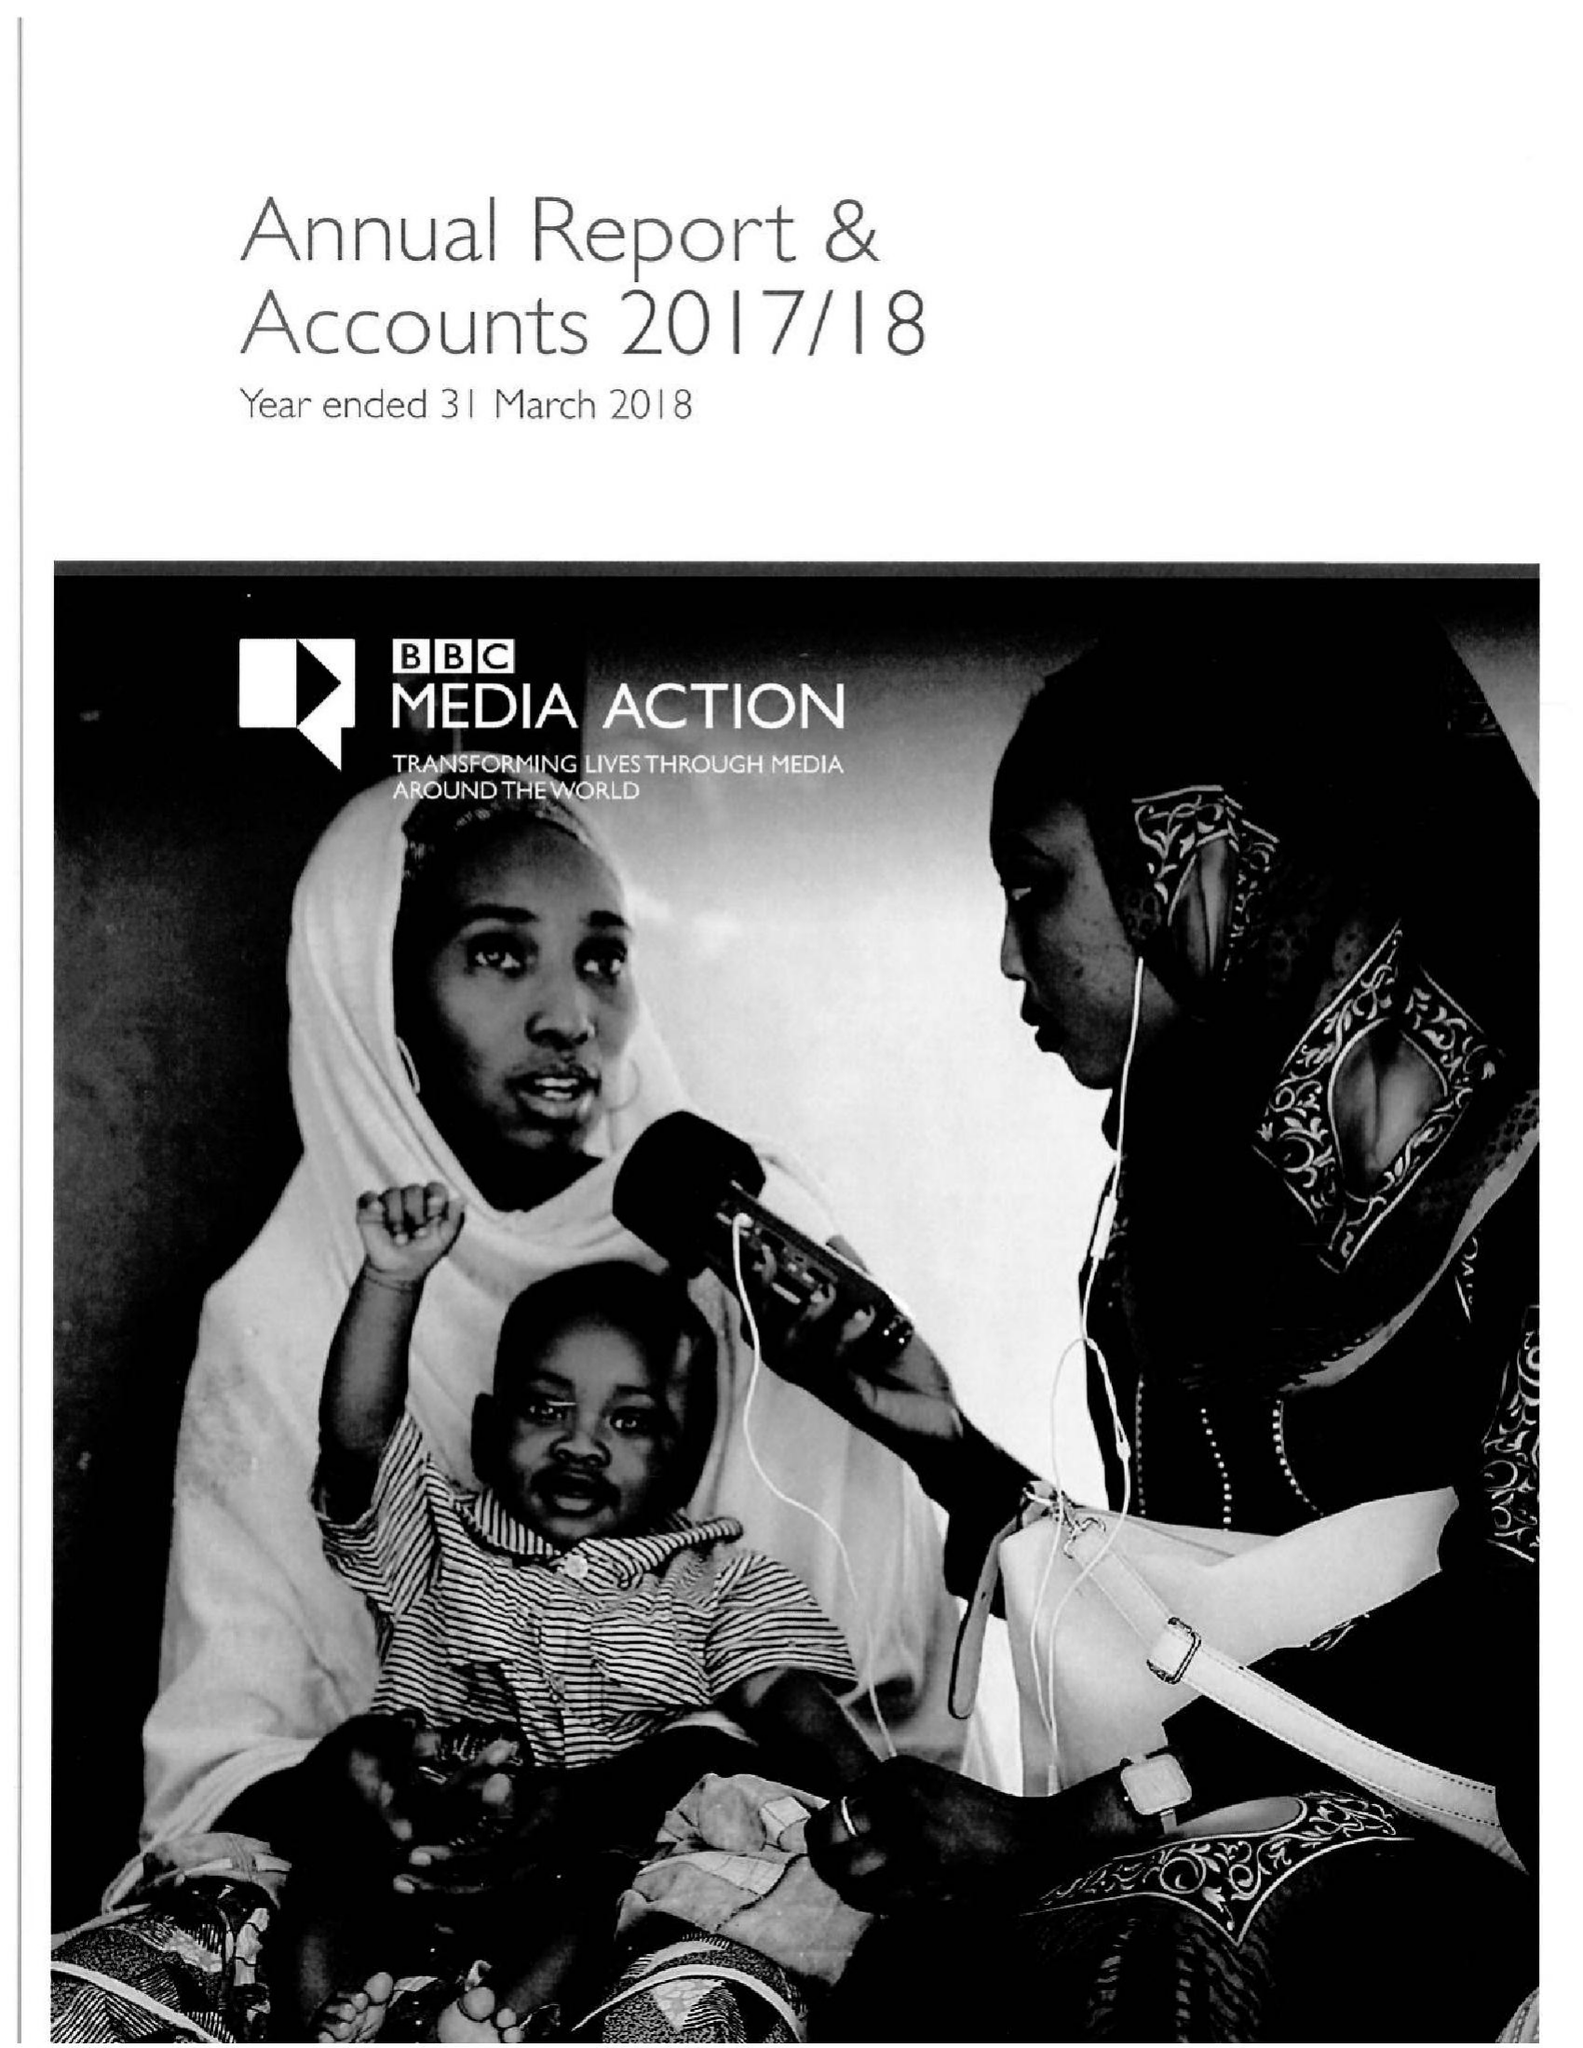What is the value for the address__post_town?
Answer the question using a single word or phrase. LONDON 